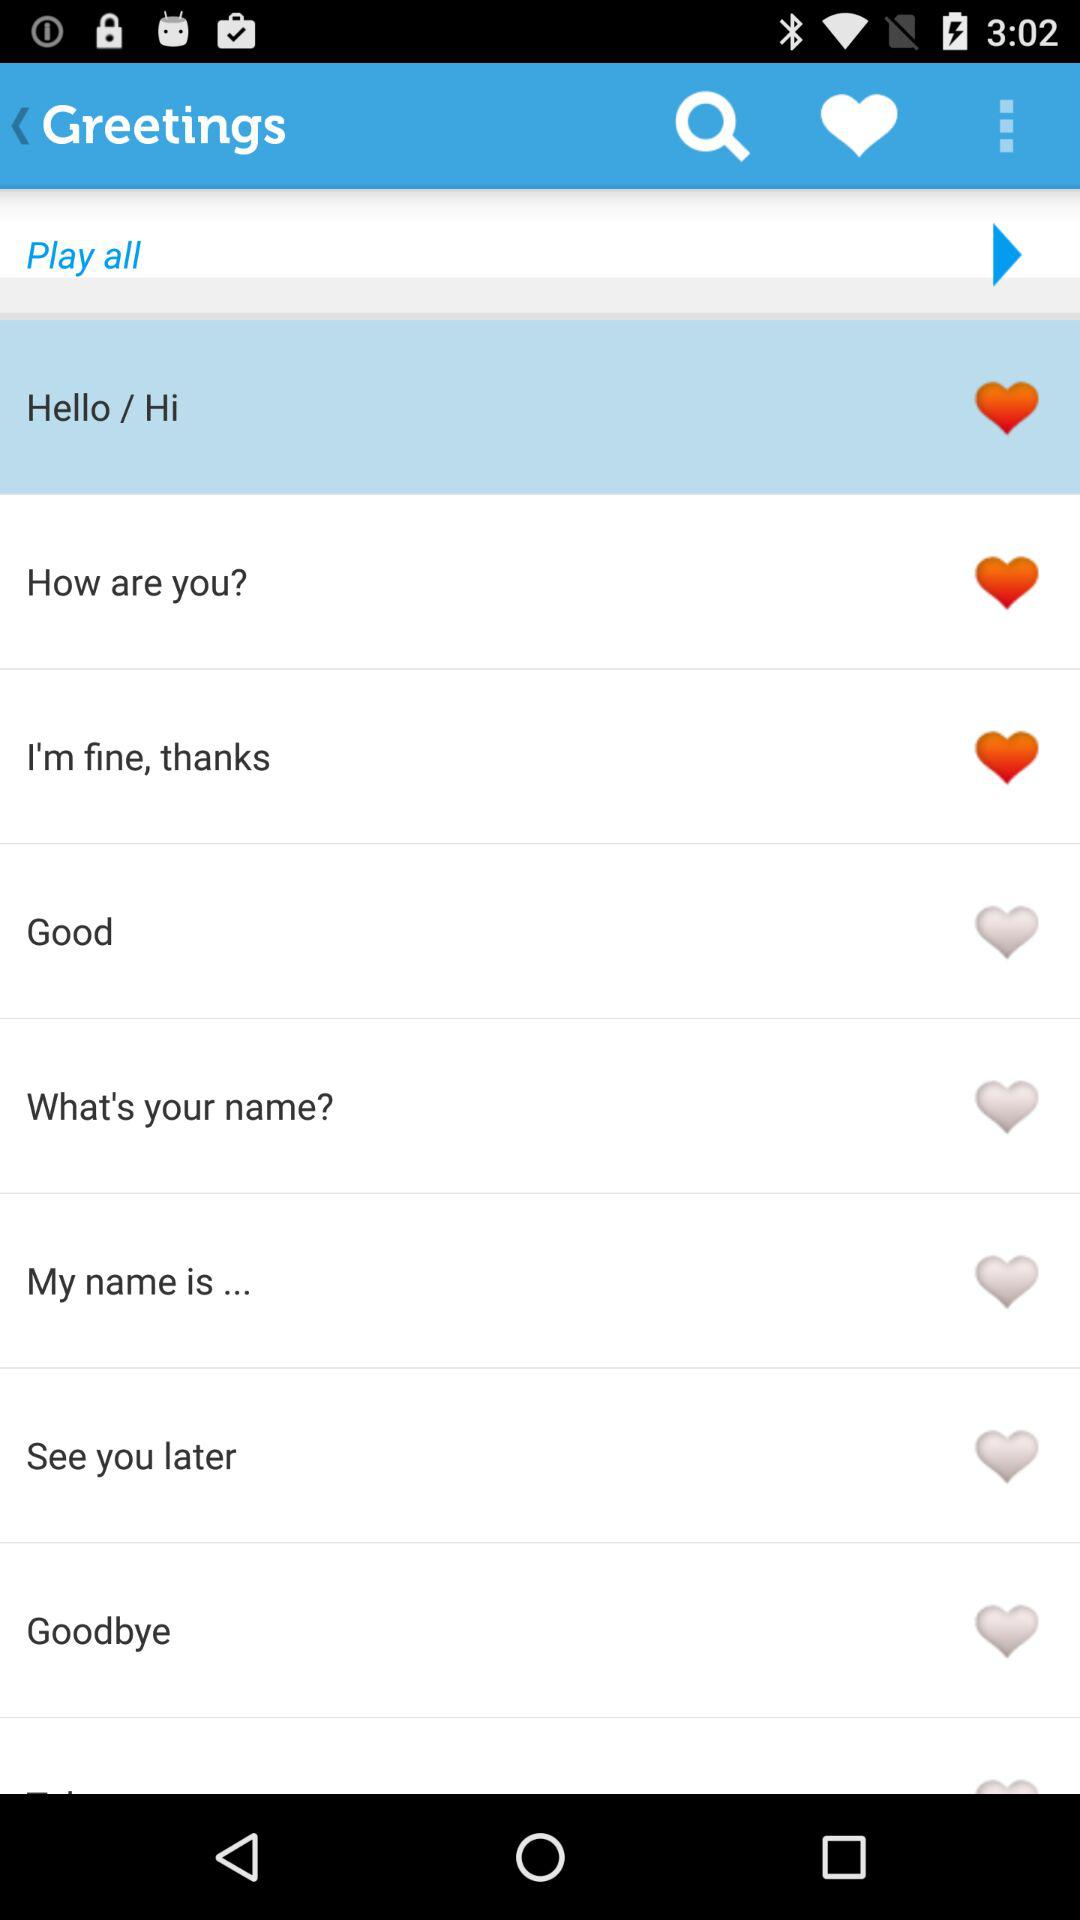What is the name of the application? The name of the application is Greetings. 